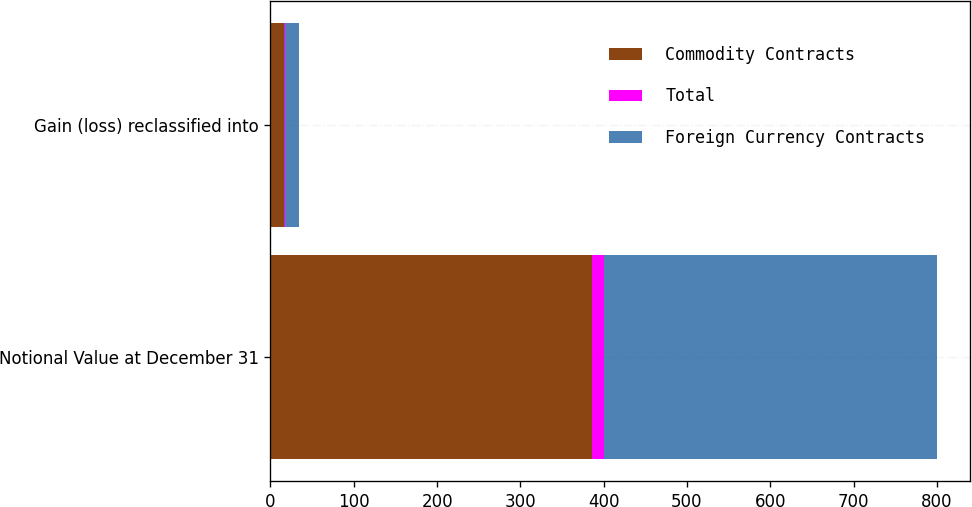Convert chart. <chart><loc_0><loc_0><loc_500><loc_500><stacked_bar_chart><ecel><fcel>Notional Value at December 31<fcel>Gain (loss) reclassified into<nl><fcel>Commodity Contracts<fcel>386<fcel>16<nl><fcel>Total<fcel>14<fcel>1<nl><fcel>Foreign Currency Contracts<fcel>400<fcel>17<nl></chart> 